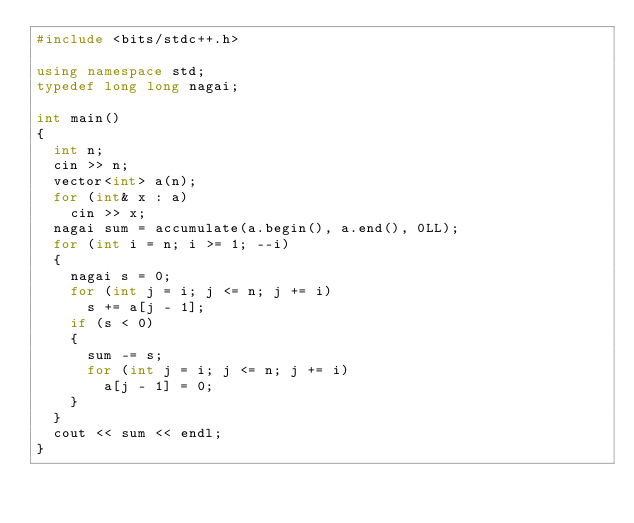Convert code to text. <code><loc_0><loc_0><loc_500><loc_500><_C++_>#include <bits/stdc++.h>

using namespace std;
typedef long long nagai;

int main()
{
	int n;
	cin >> n;
	vector<int> a(n);
	for (int& x : a)
		cin >> x;
	nagai sum = accumulate(a.begin(), a.end(), 0LL);
	for (int i = n; i >= 1; --i)
	{
		nagai s = 0;
		for (int j = i; j <= n; j += i)
			s += a[j - 1];
		if (s < 0)
		{
			sum -= s;
			for (int j = i; j <= n; j += i)
				a[j - 1] = 0;
		}
	}
	cout << sum << endl;
}
</code> 